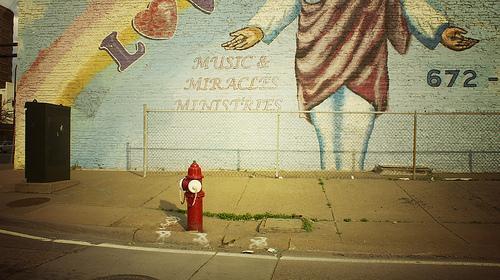How many fire hydrants are there?
Give a very brief answer. 1. 